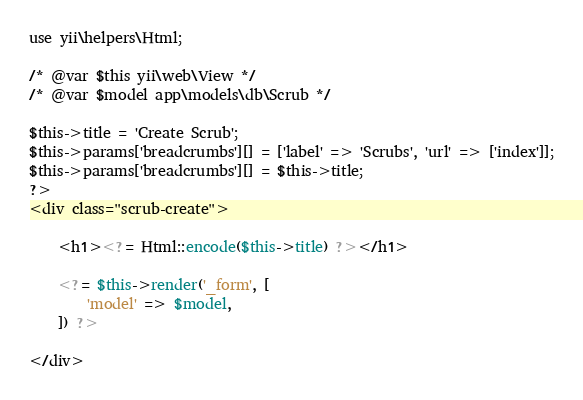Convert code to text. <code><loc_0><loc_0><loc_500><loc_500><_PHP_>
use yii\helpers\Html;

/* @var $this yii\web\View */
/* @var $model app\models\db\Scrub */

$this->title = 'Create Scrub';
$this->params['breadcrumbs'][] = ['label' => 'Scrubs', 'url' => ['index']];
$this->params['breadcrumbs'][] = $this->title;
?>
<div class="scrub-create">

    <h1><?= Html::encode($this->title) ?></h1>

    <?= $this->render('_form', [
        'model' => $model,
    ]) ?>

</div>
</code> 